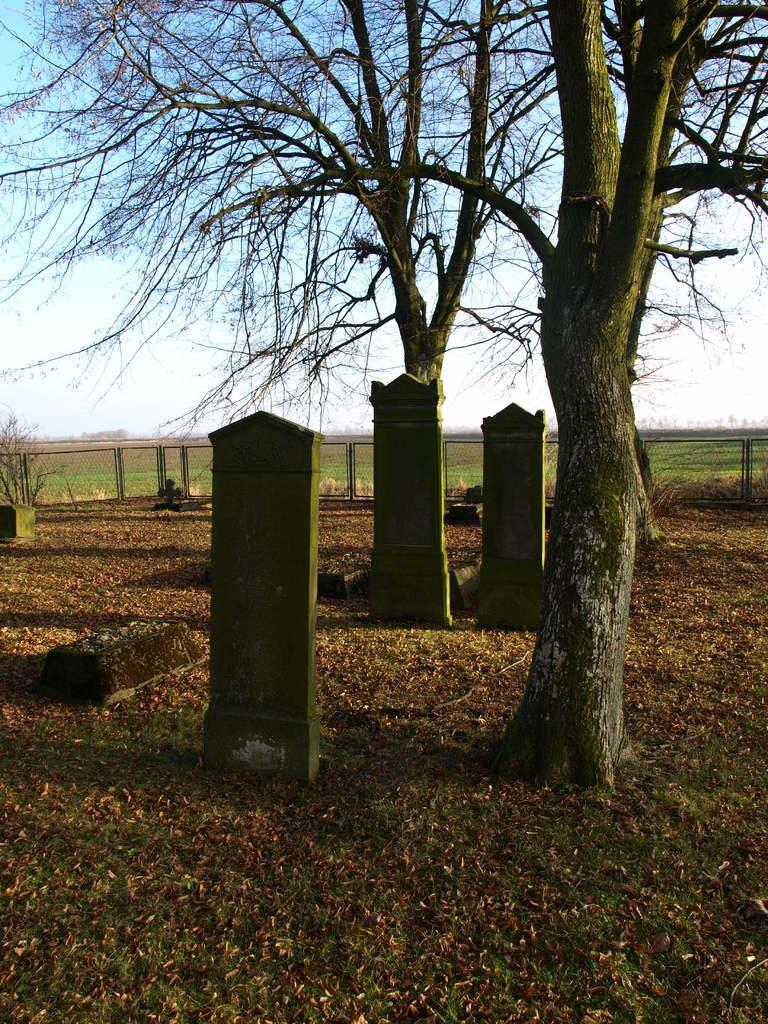What type of vegetation is present in the image? There is a group of trees in the image. What structure can be seen in the image? There is a fence in the image. What is the purpose of the area depicted in the image? The presence of graves suggests that the area is a cemetery. What can be seen in the background of the image? The sky is visible in the background of the image. Can you describe the robin perched on the dock in the image? There is no robin or dock present in the image. What type of grass is growing around the graves in the image? The image does not provide information about the type of grass, if any, growing around the graves. 